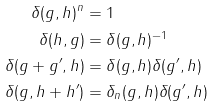Convert formula to latex. <formula><loc_0><loc_0><loc_500><loc_500>\delta ( g , h ) ^ { n } & = 1 \\ \delta ( h , g ) & = \delta ( g , h ) ^ { - 1 } \\ \delta ( g + g ^ { \prime } , h ) & = \delta ( g , h ) \delta ( g ^ { \prime } , h ) \\ \delta ( g , h + h ^ { \prime } ) & = \delta _ { n } ( g , h ) \delta ( g ^ { \prime } , h )</formula> 